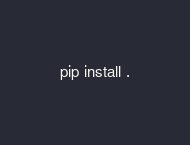<code> <loc_0><loc_0><loc_500><loc_500><_Bash_>pip install .
</code> 